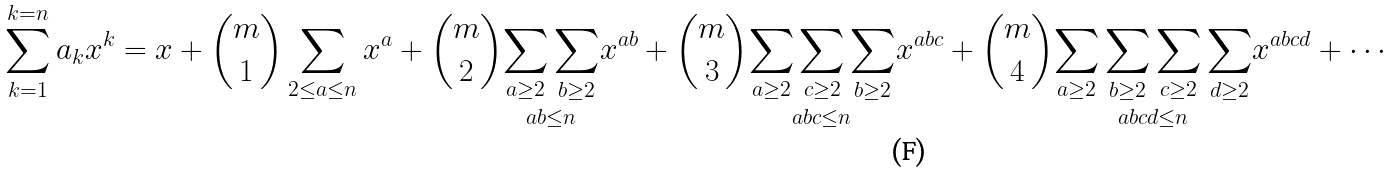<formula> <loc_0><loc_0><loc_500><loc_500>\sum _ { k = 1 } ^ { k = n } a _ { k } x ^ { k } = x + { \binom { m } { 1 } } \sum _ { 2 \leq a \leq n } x ^ { a } + { \binom { m } { 2 } } { \underset { a b \leq n } { \sum _ { a \geq 2 } \sum _ { b \geq 2 } } } x ^ { a b } + { \binom { m } { 3 } } { \underset { a b c \leq n } { \sum _ { a \geq 2 } \sum _ { c \geq 2 } \sum _ { b \geq 2 } } } x ^ { a b c } + { \binom { m } { 4 } } { \underset { a b c d \leq n } { \sum _ { a \geq 2 } \sum _ { b \geq 2 } \sum _ { c \geq 2 } \sum _ { d \geq 2 } } } x ^ { a b c d } + \cdots</formula> 